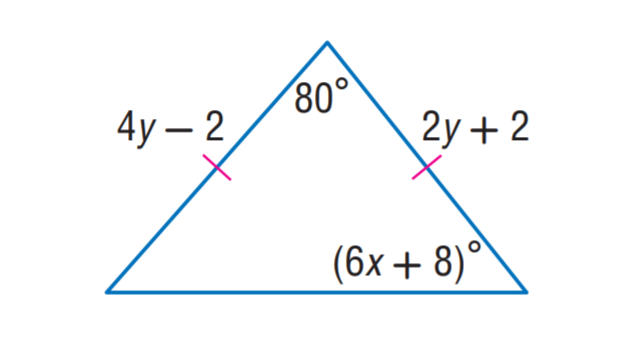Answer the mathemtical geometry problem and directly provide the correct option letter.
Question: Find y.
Choices: A: 1 B: 2 C: 3 D: 4 B 